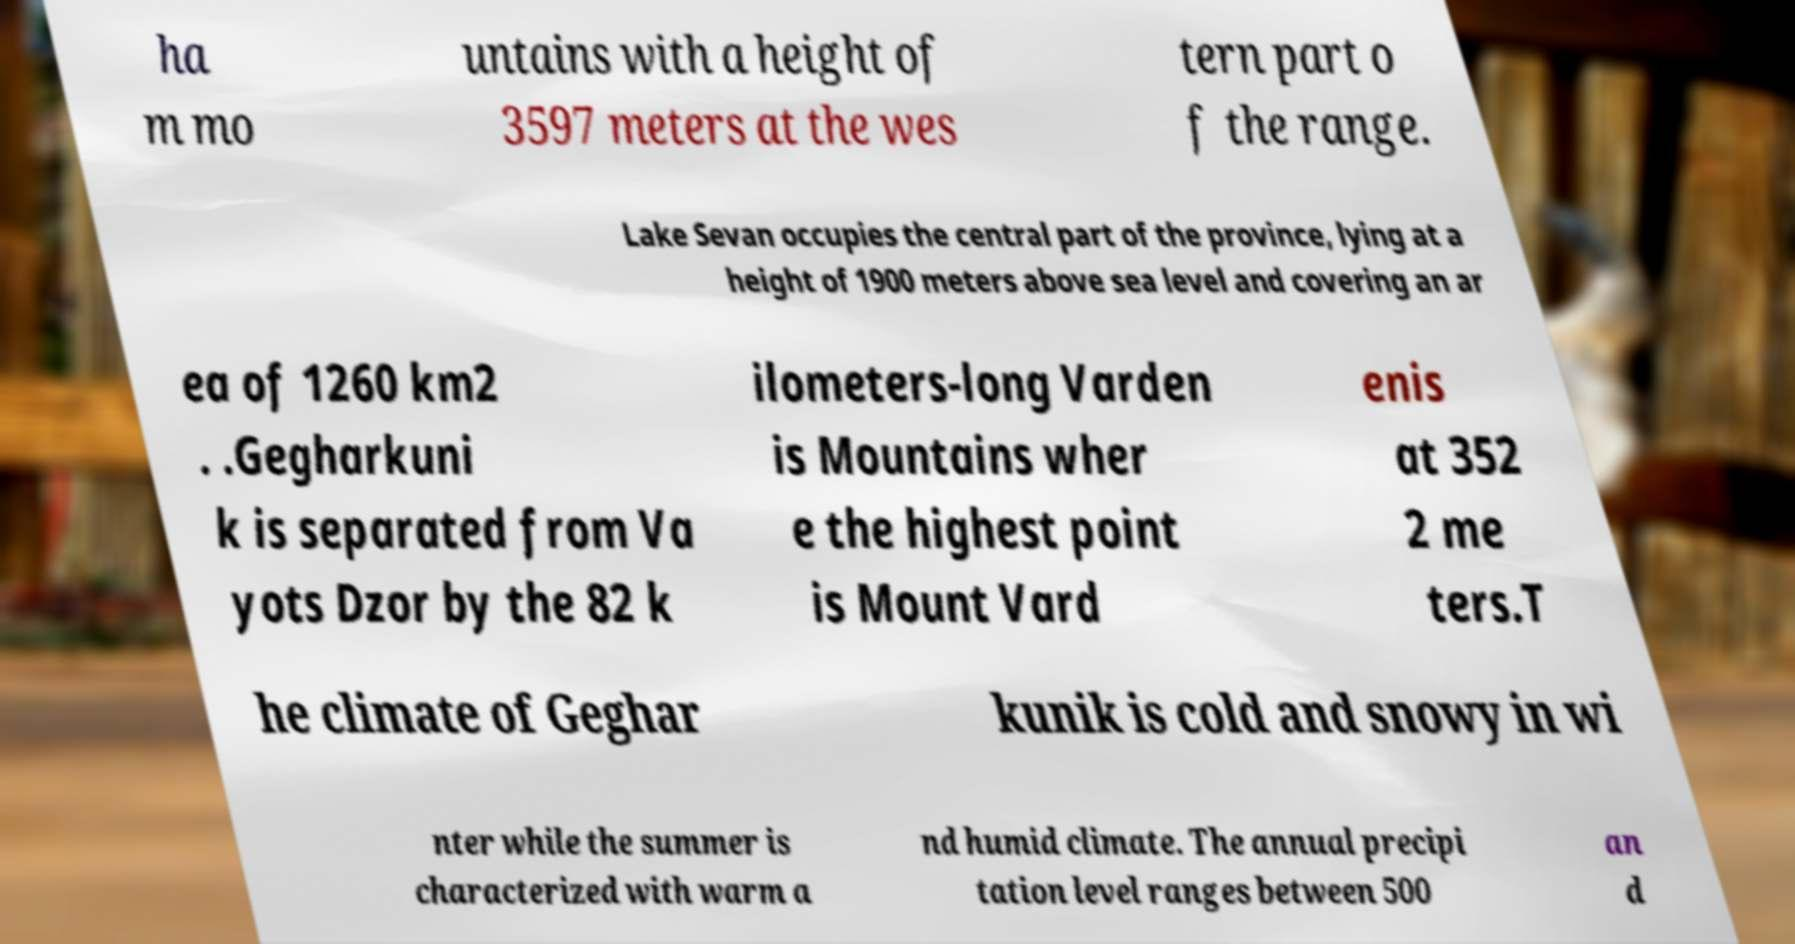What messages or text are displayed in this image? I need them in a readable, typed format. ha m mo untains with a height of 3597 meters at the wes tern part o f the range. Lake Sevan occupies the central part of the province, lying at a height of 1900 meters above sea level and covering an ar ea of 1260 km2 . .Gegharkuni k is separated from Va yots Dzor by the 82 k ilometers-long Varden is Mountains wher e the highest point is Mount Vard enis at 352 2 me ters.T he climate of Geghar kunik is cold and snowy in wi nter while the summer is characterized with warm a nd humid climate. The annual precipi tation level ranges between 500 an d 